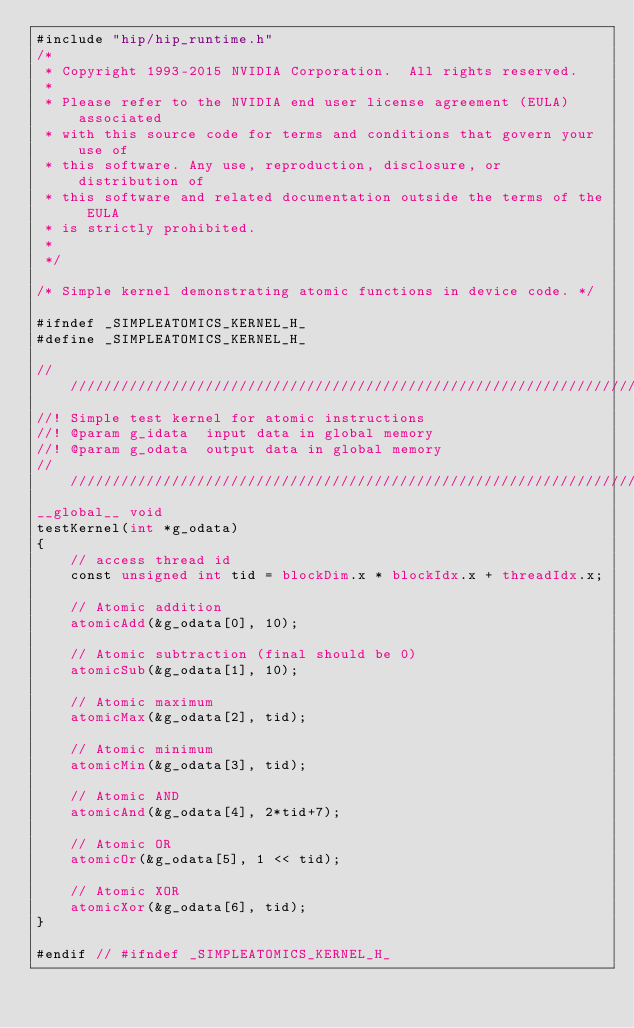<code> <loc_0><loc_0><loc_500><loc_500><_Cuda_>#include "hip/hip_runtime.h"
/*
 * Copyright 1993-2015 NVIDIA Corporation.  All rights reserved.
 *
 * Please refer to the NVIDIA end user license agreement (EULA) associated
 * with this source code for terms and conditions that govern your use of
 * this software. Any use, reproduction, disclosure, or distribution of
 * this software and related documentation outside the terms of the EULA
 * is strictly prohibited.
 *
 */

/* Simple kernel demonstrating atomic functions in device code. */

#ifndef _SIMPLEATOMICS_KERNEL_H_
#define _SIMPLEATOMICS_KERNEL_H_

////////////////////////////////////////////////////////////////////////////////
//! Simple test kernel for atomic instructions
//! @param g_idata  input data in global memory
//! @param g_odata  output data in global memory
////////////////////////////////////////////////////////////////////////////////
__global__ void
testKernel(int *g_odata)
{
    // access thread id
    const unsigned int tid = blockDim.x * blockIdx.x + threadIdx.x;

    // Atomic addition
    atomicAdd(&g_odata[0], 10);

    // Atomic subtraction (final should be 0)
    atomicSub(&g_odata[1], 10);

    // Atomic maximum
    atomicMax(&g_odata[2], tid);

    // Atomic minimum
    atomicMin(&g_odata[3], tid);

    // Atomic AND
    atomicAnd(&g_odata[4], 2*tid+7);

    // Atomic OR
    atomicOr(&g_odata[5], 1 << tid);

    // Atomic XOR
    atomicXor(&g_odata[6], tid);
}

#endif // #ifndef _SIMPLEATOMICS_KERNEL_H_
</code> 